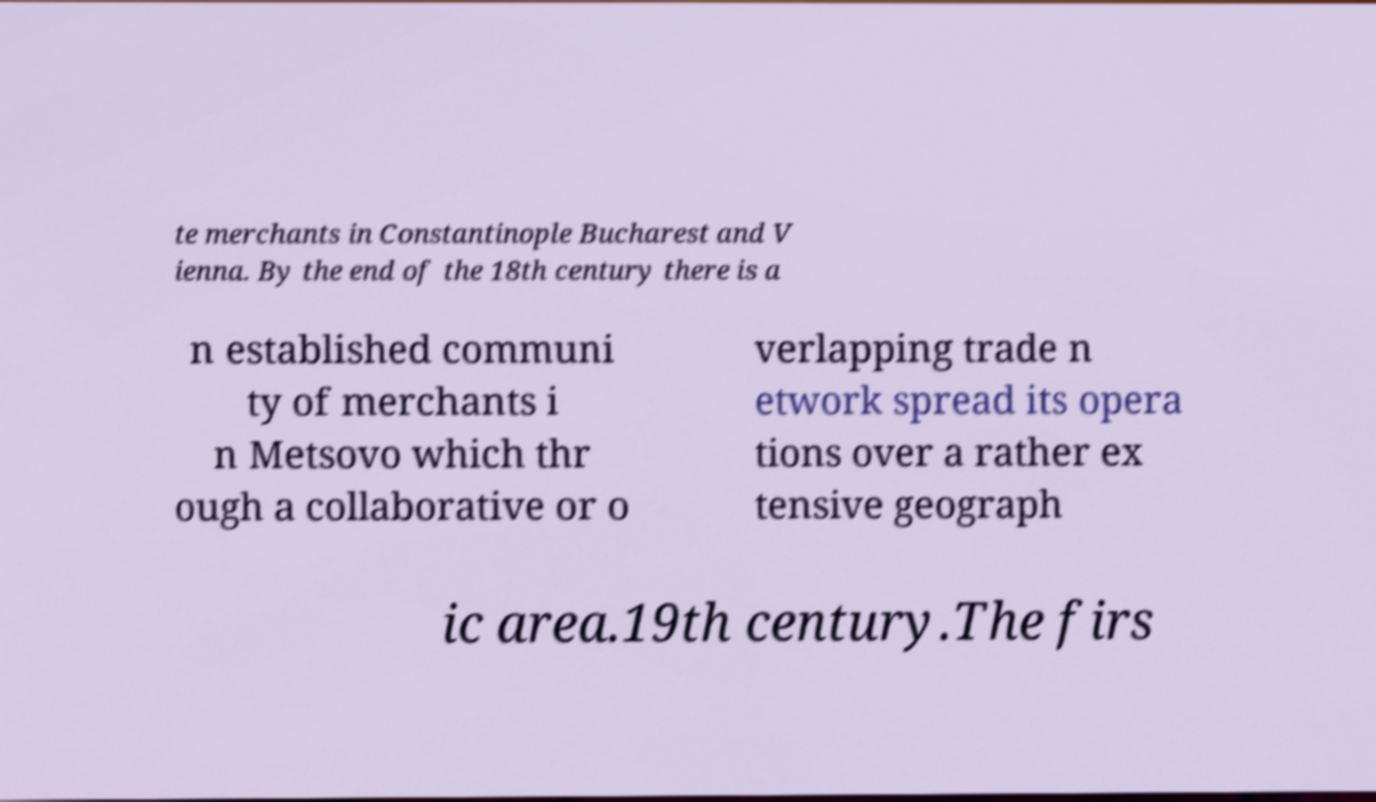Could you assist in decoding the text presented in this image and type it out clearly? te merchants in Constantinople Bucharest and V ienna. By the end of the 18th century there is a n established communi ty of merchants i n Metsovo which thr ough a collaborative or o verlapping trade n etwork spread its opera tions over a rather ex tensive geograph ic area.19th century.The firs 